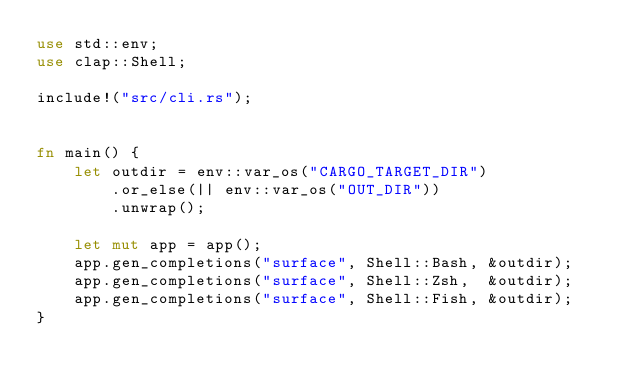<code> <loc_0><loc_0><loc_500><loc_500><_Rust_>use std::env;
use clap::Shell;

include!("src/cli.rs");


fn main() {
    let outdir = env::var_os("CARGO_TARGET_DIR")
        .or_else(|| env::var_os("OUT_DIR"))
        .unwrap();

    let mut app = app();
    app.gen_completions("surface", Shell::Bash, &outdir);
    app.gen_completions("surface", Shell::Zsh,  &outdir);
    app.gen_completions("surface", Shell::Fish, &outdir);
}</code> 